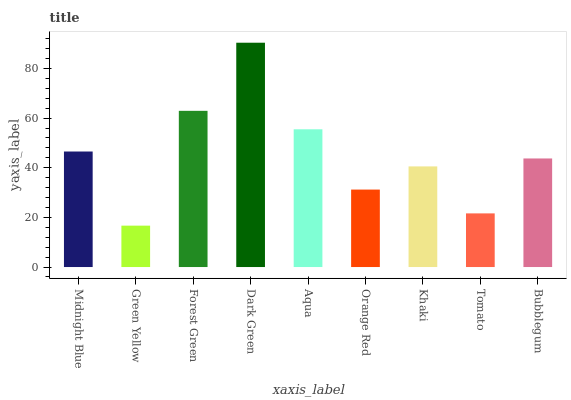Is Forest Green the minimum?
Answer yes or no. No. Is Forest Green the maximum?
Answer yes or no. No. Is Forest Green greater than Green Yellow?
Answer yes or no. Yes. Is Green Yellow less than Forest Green?
Answer yes or no. Yes. Is Green Yellow greater than Forest Green?
Answer yes or no. No. Is Forest Green less than Green Yellow?
Answer yes or no. No. Is Bubblegum the high median?
Answer yes or no. Yes. Is Bubblegum the low median?
Answer yes or no. Yes. Is Green Yellow the high median?
Answer yes or no. No. Is Green Yellow the low median?
Answer yes or no. No. 